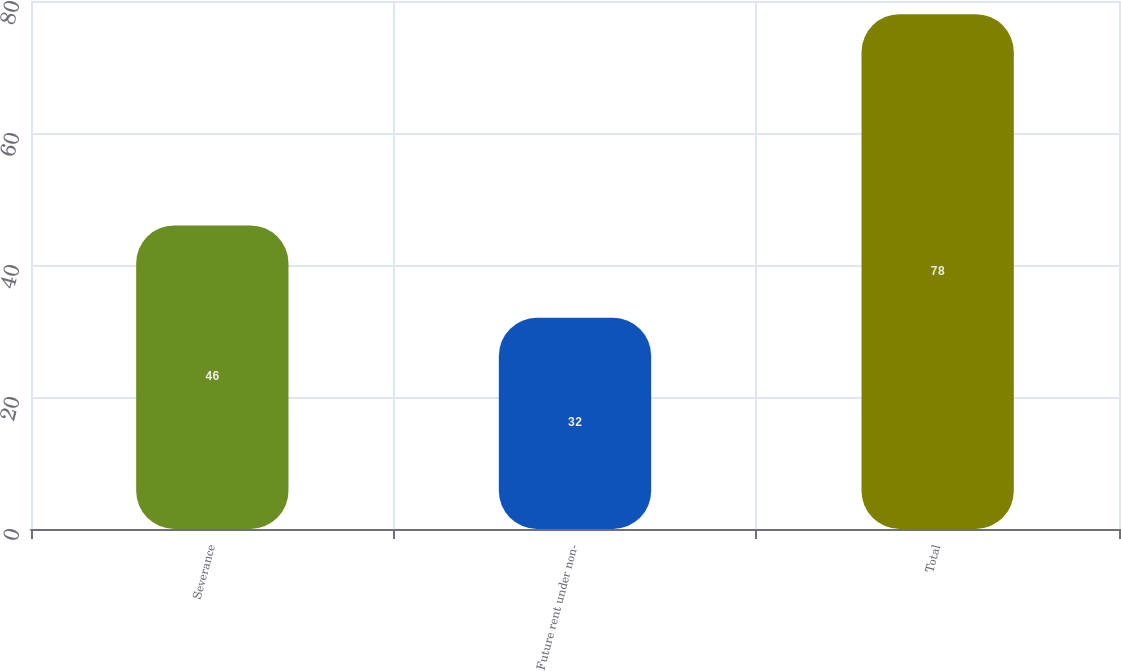Convert chart to OTSL. <chart><loc_0><loc_0><loc_500><loc_500><bar_chart><fcel>Severance<fcel>Future rent under non-<fcel>Total<nl><fcel>46<fcel>32<fcel>78<nl></chart> 